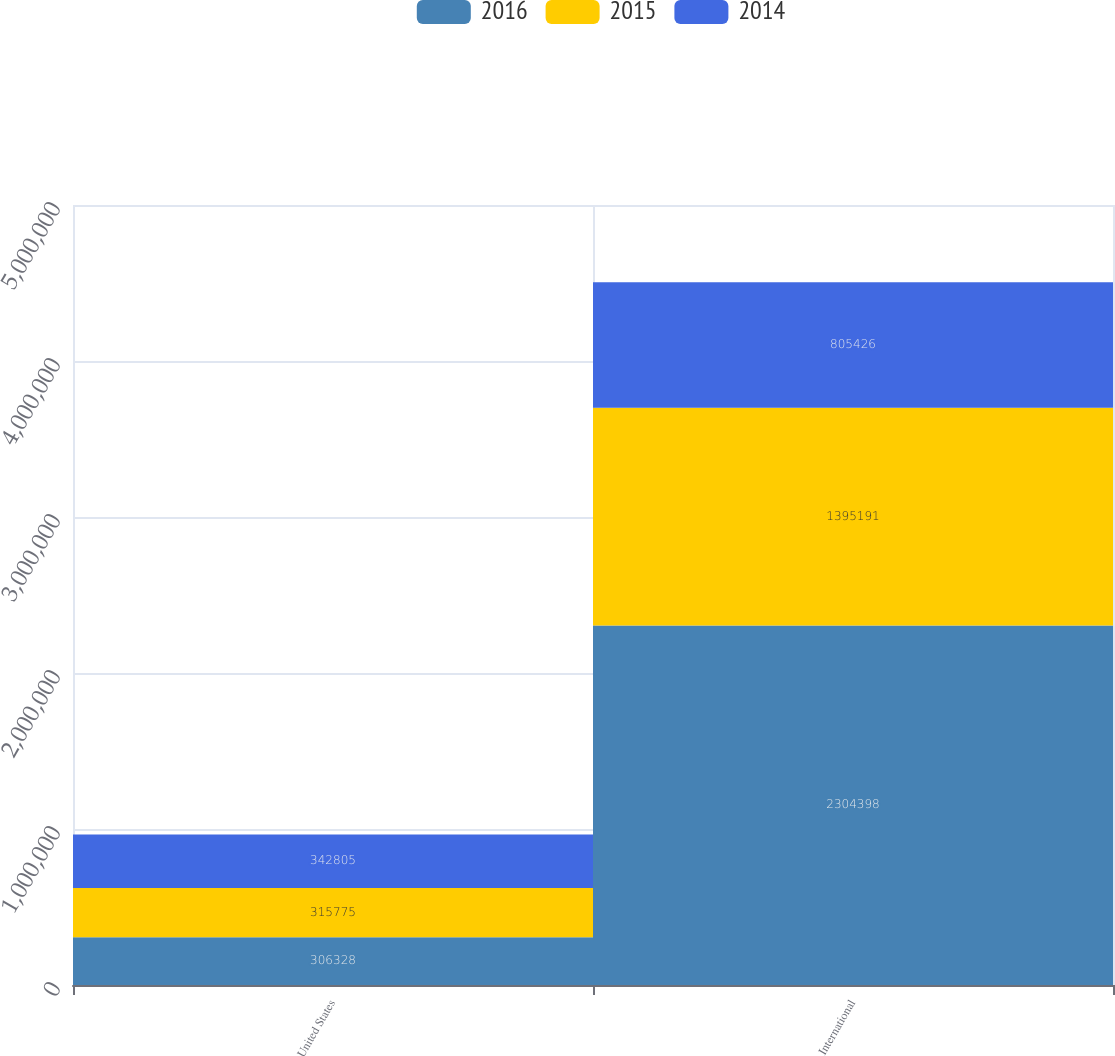Convert chart to OTSL. <chart><loc_0><loc_0><loc_500><loc_500><stacked_bar_chart><ecel><fcel>United States<fcel>International<nl><fcel>2016<fcel>306328<fcel>2.3044e+06<nl><fcel>2015<fcel>315775<fcel>1.39519e+06<nl><fcel>2014<fcel>342805<fcel>805426<nl></chart> 